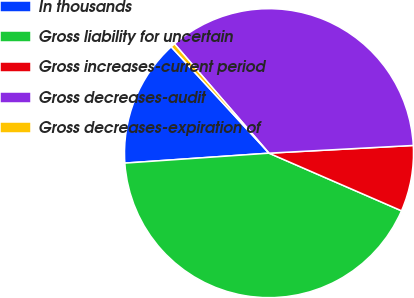<chart> <loc_0><loc_0><loc_500><loc_500><pie_chart><fcel>In thousands<fcel>Gross liability for uncertain<fcel>Gross increases-current period<fcel>Gross decreases-audit<fcel>Gross decreases-expiration of<nl><fcel>14.26%<fcel>42.37%<fcel>7.38%<fcel>35.49%<fcel>0.49%<nl></chart> 